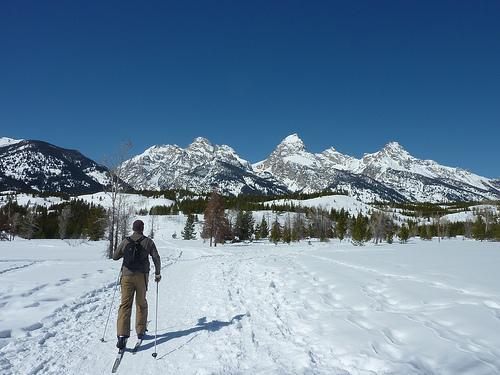How many people are there?
Give a very brief answer. 1. 